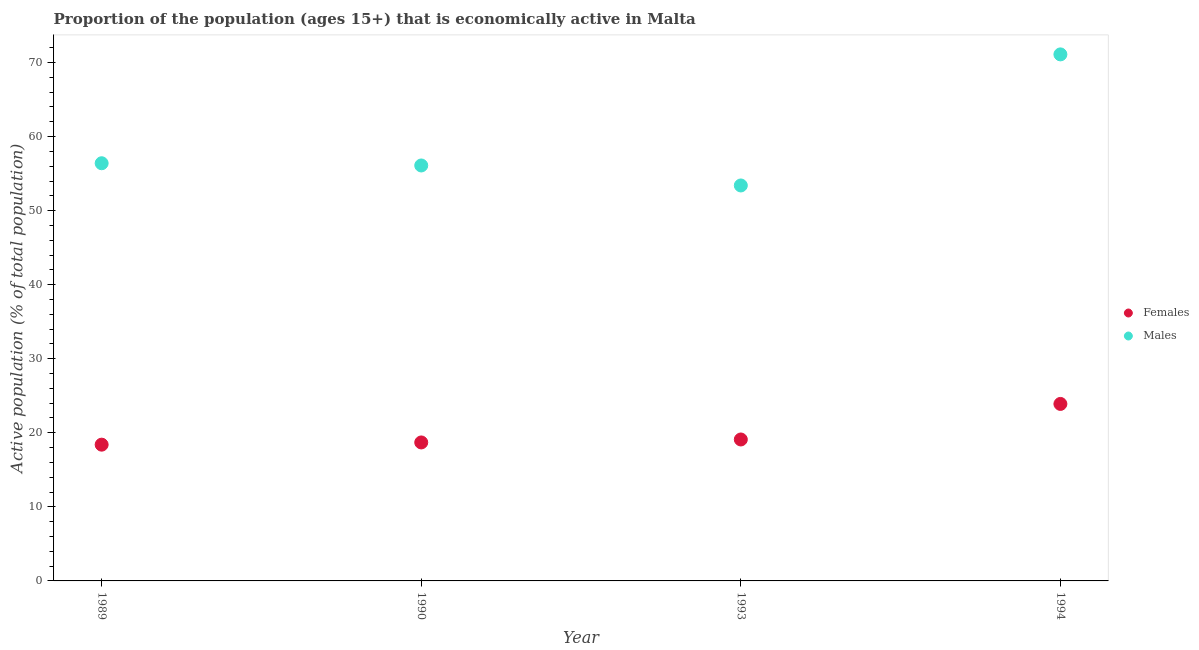How many different coloured dotlines are there?
Offer a very short reply. 2. What is the percentage of economically active male population in 1993?
Offer a very short reply. 53.4. Across all years, what is the maximum percentage of economically active female population?
Offer a very short reply. 23.9. Across all years, what is the minimum percentage of economically active male population?
Provide a succinct answer. 53.4. In which year was the percentage of economically active female population minimum?
Provide a succinct answer. 1989. What is the total percentage of economically active male population in the graph?
Your answer should be very brief. 237. What is the difference between the percentage of economically active female population in 1989 and that in 1994?
Ensure brevity in your answer.  -5.5. What is the difference between the percentage of economically active male population in 1994 and the percentage of economically active female population in 1993?
Make the answer very short. 52. What is the average percentage of economically active male population per year?
Provide a short and direct response. 59.25. In the year 1990, what is the difference between the percentage of economically active male population and percentage of economically active female population?
Make the answer very short. 37.4. What is the ratio of the percentage of economically active female population in 1990 to that in 1993?
Offer a terse response. 0.98. Is the percentage of economically active female population in 1989 less than that in 1990?
Provide a short and direct response. Yes. Is the difference between the percentage of economically active male population in 1993 and 1994 greater than the difference between the percentage of economically active female population in 1993 and 1994?
Offer a terse response. No. What is the difference between the highest and the second highest percentage of economically active female population?
Keep it short and to the point. 4.8. What is the difference between the highest and the lowest percentage of economically active female population?
Offer a very short reply. 5.5. In how many years, is the percentage of economically active male population greater than the average percentage of economically active male population taken over all years?
Your answer should be very brief. 1. Does the percentage of economically active female population monotonically increase over the years?
Offer a terse response. Yes. Is the percentage of economically active male population strictly less than the percentage of economically active female population over the years?
Give a very brief answer. No. How many dotlines are there?
Your answer should be compact. 2. Are the values on the major ticks of Y-axis written in scientific E-notation?
Keep it short and to the point. No. Where does the legend appear in the graph?
Your answer should be compact. Center right. What is the title of the graph?
Offer a terse response. Proportion of the population (ages 15+) that is economically active in Malta. What is the label or title of the Y-axis?
Provide a succinct answer. Active population (% of total population). What is the Active population (% of total population) in Females in 1989?
Give a very brief answer. 18.4. What is the Active population (% of total population) in Males in 1989?
Your answer should be compact. 56.4. What is the Active population (% of total population) in Females in 1990?
Offer a very short reply. 18.7. What is the Active population (% of total population) of Males in 1990?
Your response must be concise. 56.1. What is the Active population (% of total population) in Females in 1993?
Offer a very short reply. 19.1. What is the Active population (% of total population) of Males in 1993?
Give a very brief answer. 53.4. What is the Active population (% of total population) in Females in 1994?
Offer a very short reply. 23.9. What is the Active population (% of total population) of Males in 1994?
Provide a short and direct response. 71.1. Across all years, what is the maximum Active population (% of total population) in Females?
Your answer should be compact. 23.9. Across all years, what is the maximum Active population (% of total population) in Males?
Give a very brief answer. 71.1. Across all years, what is the minimum Active population (% of total population) in Females?
Provide a succinct answer. 18.4. Across all years, what is the minimum Active population (% of total population) in Males?
Your answer should be compact. 53.4. What is the total Active population (% of total population) of Females in the graph?
Keep it short and to the point. 80.1. What is the total Active population (% of total population) in Males in the graph?
Keep it short and to the point. 237. What is the difference between the Active population (% of total population) in Females in 1989 and that in 1990?
Your answer should be compact. -0.3. What is the difference between the Active population (% of total population) of Males in 1989 and that in 1990?
Your answer should be very brief. 0.3. What is the difference between the Active population (% of total population) in Males in 1989 and that in 1993?
Provide a short and direct response. 3. What is the difference between the Active population (% of total population) in Males in 1989 and that in 1994?
Offer a very short reply. -14.7. What is the difference between the Active population (% of total population) in Males in 1990 and that in 1993?
Ensure brevity in your answer.  2.7. What is the difference between the Active population (% of total population) of Females in 1990 and that in 1994?
Provide a short and direct response. -5.2. What is the difference between the Active population (% of total population) of Males in 1993 and that in 1994?
Your answer should be compact. -17.7. What is the difference between the Active population (% of total population) in Females in 1989 and the Active population (% of total population) in Males in 1990?
Offer a terse response. -37.7. What is the difference between the Active population (% of total population) of Females in 1989 and the Active population (% of total population) of Males in 1993?
Ensure brevity in your answer.  -35. What is the difference between the Active population (% of total population) of Females in 1989 and the Active population (% of total population) of Males in 1994?
Provide a short and direct response. -52.7. What is the difference between the Active population (% of total population) of Females in 1990 and the Active population (% of total population) of Males in 1993?
Your answer should be very brief. -34.7. What is the difference between the Active population (% of total population) of Females in 1990 and the Active population (% of total population) of Males in 1994?
Your answer should be compact. -52.4. What is the difference between the Active population (% of total population) in Females in 1993 and the Active population (% of total population) in Males in 1994?
Offer a very short reply. -52. What is the average Active population (% of total population) of Females per year?
Provide a short and direct response. 20.02. What is the average Active population (% of total population) in Males per year?
Keep it short and to the point. 59.25. In the year 1989, what is the difference between the Active population (% of total population) in Females and Active population (% of total population) in Males?
Provide a succinct answer. -38. In the year 1990, what is the difference between the Active population (% of total population) in Females and Active population (% of total population) in Males?
Ensure brevity in your answer.  -37.4. In the year 1993, what is the difference between the Active population (% of total population) of Females and Active population (% of total population) of Males?
Provide a short and direct response. -34.3. In the year 1994, what is the difference between the Active population (% of total population) in Females and Active population (% of total population) in Males?
Offer a terse response. -47.2. What is the ratio of the Active population (% of total population) of Females in 1989 to that in 1993?
Keep it short and to the point. 0.96. What is the ratio of the Active population (% of total population) of Males in 1989 to that in 1993?
Give a very brief answer. 1.06. What is the ratio of the Active population (% of total population) in Females in 1989 to that in 1994?
Keep it short and to the point. 0.77. What is the ratio of the Active population (% of total population) in Males in 1989 to that in 1994?
Offer a terse response. 0.79. What is the ratio of the Active population (% of total population) of Females in 1990 to that in 1993?
Provide a succinct answer. 0.98. What is the ratio of the Active population (% of total population) of Males in 1990 to that in 1993?
Make the answer very short. 1.05. What is the ratio of the Active population (% of total population) of Females in 1990 to that in 1994?
Ensure brevity in your answer.  0.78. What is the ratio of the Active population (% of total population) in Males in 1990 to that in 1994?
Your response must be concise. 0.79. What is the ratio of the Active population (% of total population) in Females in 1993 to that in 1994?
Provide a succinct answer. 0.8. What is the ratio of the Active population (% of total population) in Males in 1993 to that in 1994?
Offer a very short reply. 0.75. What is the difference between the highest and the second highest Active population (% of total population) in Males?
Provide a short and direct response. 14.7. 